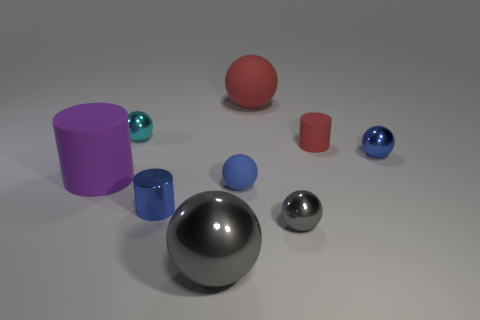Subtract all blue metallic spheres. How many spheres are left? 5 Subtract 3 balls. How many balls are left? 3 Subtract all cyan balls. How many balls are left? 5 Add 1 large blue rubber things. How many objects exist? 10 Subtract all blue spheres. Subtract all red cylinders. How many spheres are left? 4 Subtract all cylinders. How many objects are left? 6 Subtract 1 red cylinders. How many objects are left? 8 Subtract all cyan spheres. Subtract all green matte spheres. How many objects are left? 8 Add 1 tiny cyan metal balls. How many tiny cyan metal balls are left? 2 Add 3 small gray shiny things. How many small gray shiny things exist? 4 